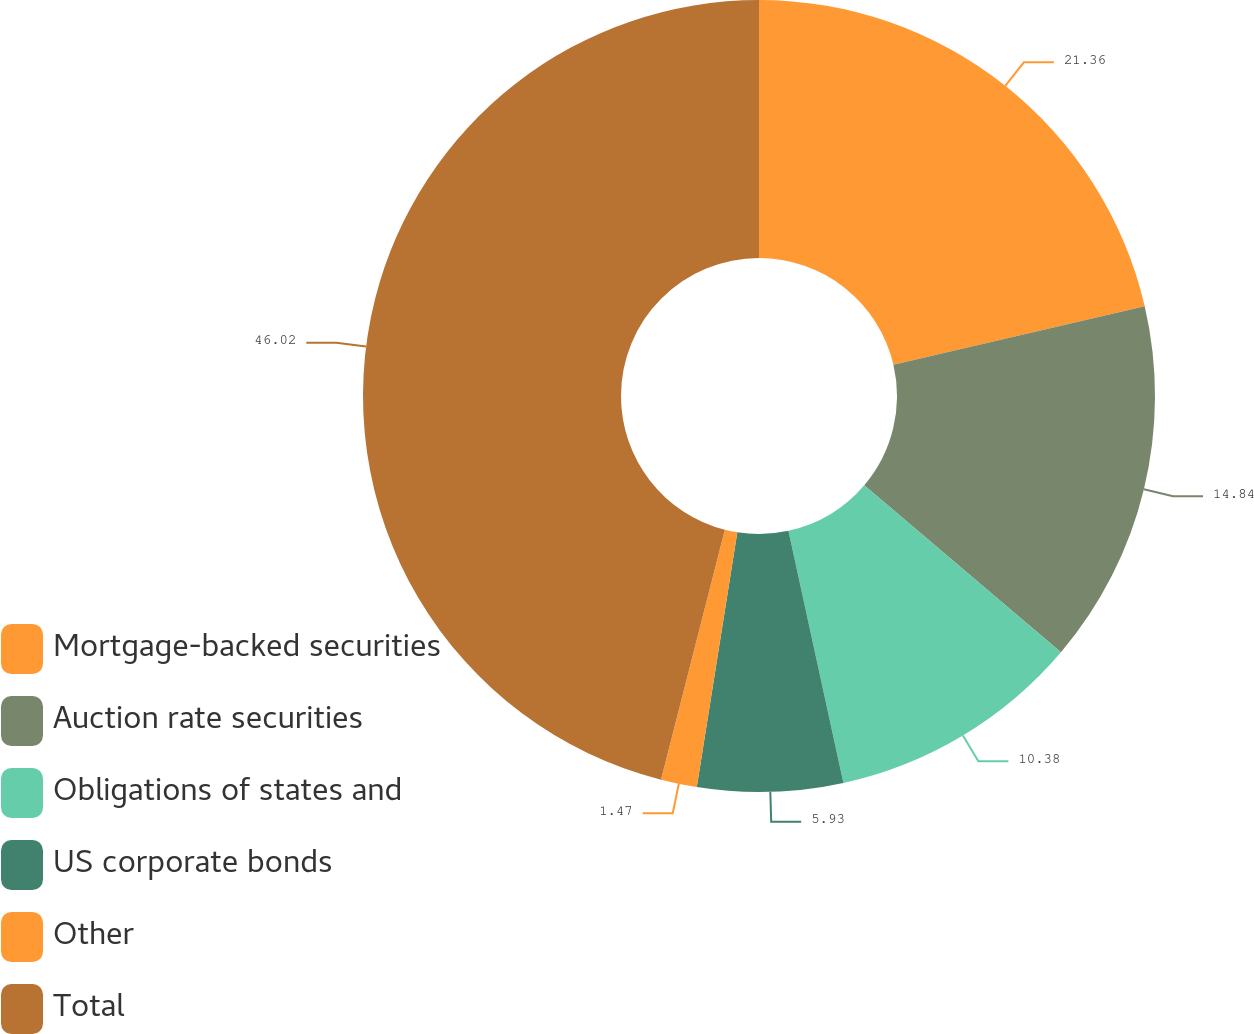Convert chart. <chart><loc_0><loc_0><loc_500><loc_500><pie_chart><fcel>Mortgage-backed securities<fcel>Auction rate securities<fcel>Obligations of states and<fcel>US corporate bonds<fcel>Other<fcel>Total<nl><fcel>21.36%<fcel>14.84%<fcel>10.38%<fcel>5.93%<fcel>1.47%<fcel>46.02%<nl></chart> 